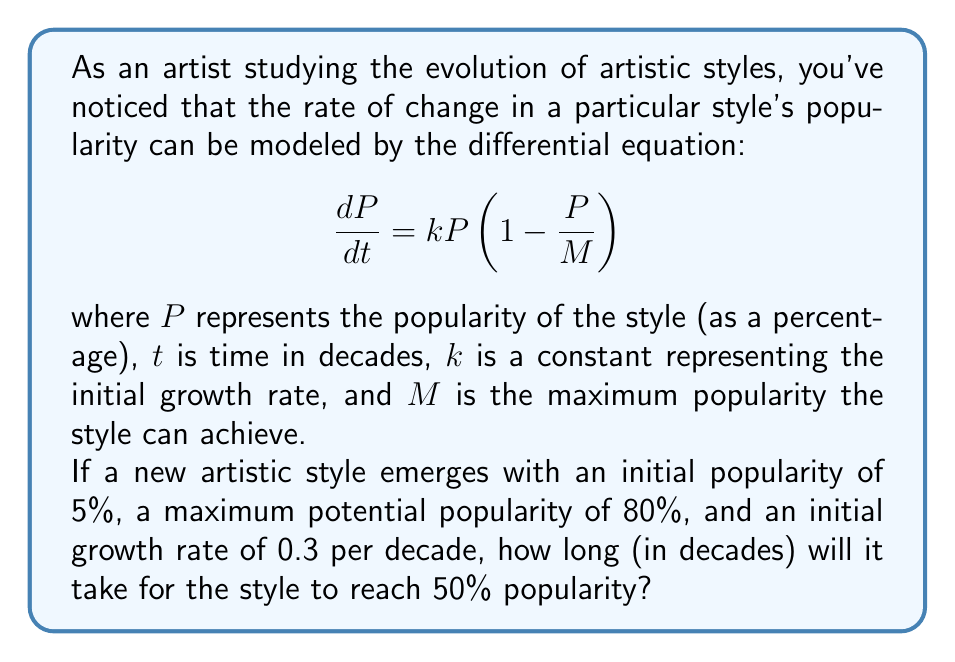Solve this math problem. To solve this problem, we need to use the given differential equation and integrate it to find the popularity as a function of time. Then, we can solve for the time when the popularity reaches 50%.

1. The given differential equation is a logistic growth model:

   $$\frac{dP}{dt} = kP(1-\frac{P}{M})$$

2. The solution to this equation is:

   $$P(t) = \frac{M}{1 + (\frac{M}{P_0} - 1)e^{-kt}}$$

   where $P_0$ is the initial popularity.

3. We're given the following values:
   - $P_0 = 5\%$ (initial popularity)
   - $M = 80\%$ (maximum popularity)
   - $k = 0.3$ (initial growth rate per decade)

4. Substituting these values into the equation:

   $$P(t) = \frac{80}{1 + (\frac{80}{5} - 1)e^{-0.3t}}$$

5. We want to find $t$ when $P(t) = 50\%$. Let's substitute this:

   $$50 = \frac{80}{1 + (\frac{80}{5} - 1)e^{-0.3t}}$$

6. Solving for $t$:

   $$1 + (\frac{80}{5} - 1)e^{-0.3t} = \frac{80}{50} = 1.6$$
   
   $$(\frac{80}{5} - 1)e^{-0.3t} = 0.6$$
   
   $$e^{-0.3t} = \frac{0.6}{15} = 0.04$$
   
   $$-0.3t = \ln(0.04)$$
   
   $$t = -\frac{\ln(0.04)}{0.3} \approx 10.68$$

Therefore, it will take approximately 10.68 decades for the artistic style to reach 50% popularity.
Answer: $10.68$ decades 